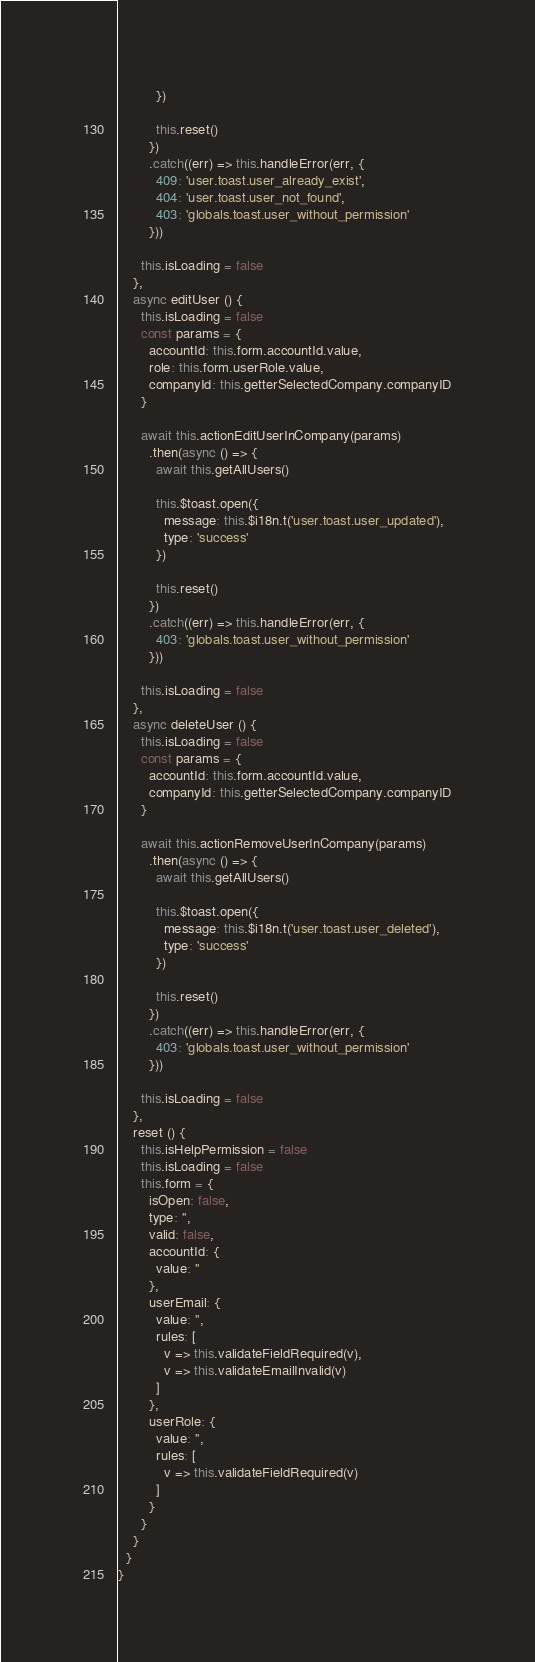<code> <loc_0><loc_0><loc_500><loc_500><_JavaScript_>          })

          this.reset()
        })
        .catch((err) => this.handleError(err, {
          409: 'user.toast.user_already_exist',
          404: 'user.toast.user_not_found',
          403: 'globals.toast.user_without_permission'
        }))

      this.isLoading = false
    },
    async editUser () {
      this.isLoading = false
      const params = {
        accountId: this.form.accountId.value,
        role: this.form.userRole.value,
        companyId: this.getterSelectedCompany.companyID
      }

      await this.actionEditUserInCompany(params)
        .then(async () => {
          await this.getAllUsers()

          this.$toast.open({
            message: this.$i18n.t('user.toast.user_updated'),
            type: 'success'
          })

          this.reset()
        })
        .catch((err) => this.handleError(err, {
          403: 'globals.toast.user_without_permission'
        }))

      this.isLoading = false
    },
    async deleteUser () {
      this.isLoading = false
      const params = {
        accountId: this.form.accountId.value,
        companyId: this.getterSelectedCompany.companyID
      }

      await this.actionRemoveUserInCompany(params)
        .then(async () => {
          await this.getAllUsers()

          this.$toast.open({
            message: this.$i18n.t('user.toast.user_deleted'),
            type: 'success'
          })

          this.reset()
        })
        .catch((err) => this.handleError(err, {
          403: 'globals.toast.user_without_permission'
        }))

      this.isLoading = false
    },
    reset () {
      this.isHelpPermission = false
      this.isLoading = false
      this.form = {
        isOpen: false,
        type: '',
        valid: false,
        accountId: {
          value: ''
        },
        userEmail: {
          value: '',
          rules: [
            v => this.validateFieldRequired(v),
            v => this.validateEmailInvalid(v)
          ]
        },
        userRole: {
          value: '',
          rules: [
            v => this.validateFieldRequired(v)
          ]
        }
      }
    }
  }
}
</code> 